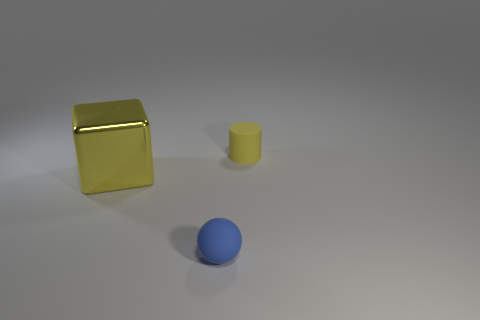What number of small yellow cylinders are there? 1 